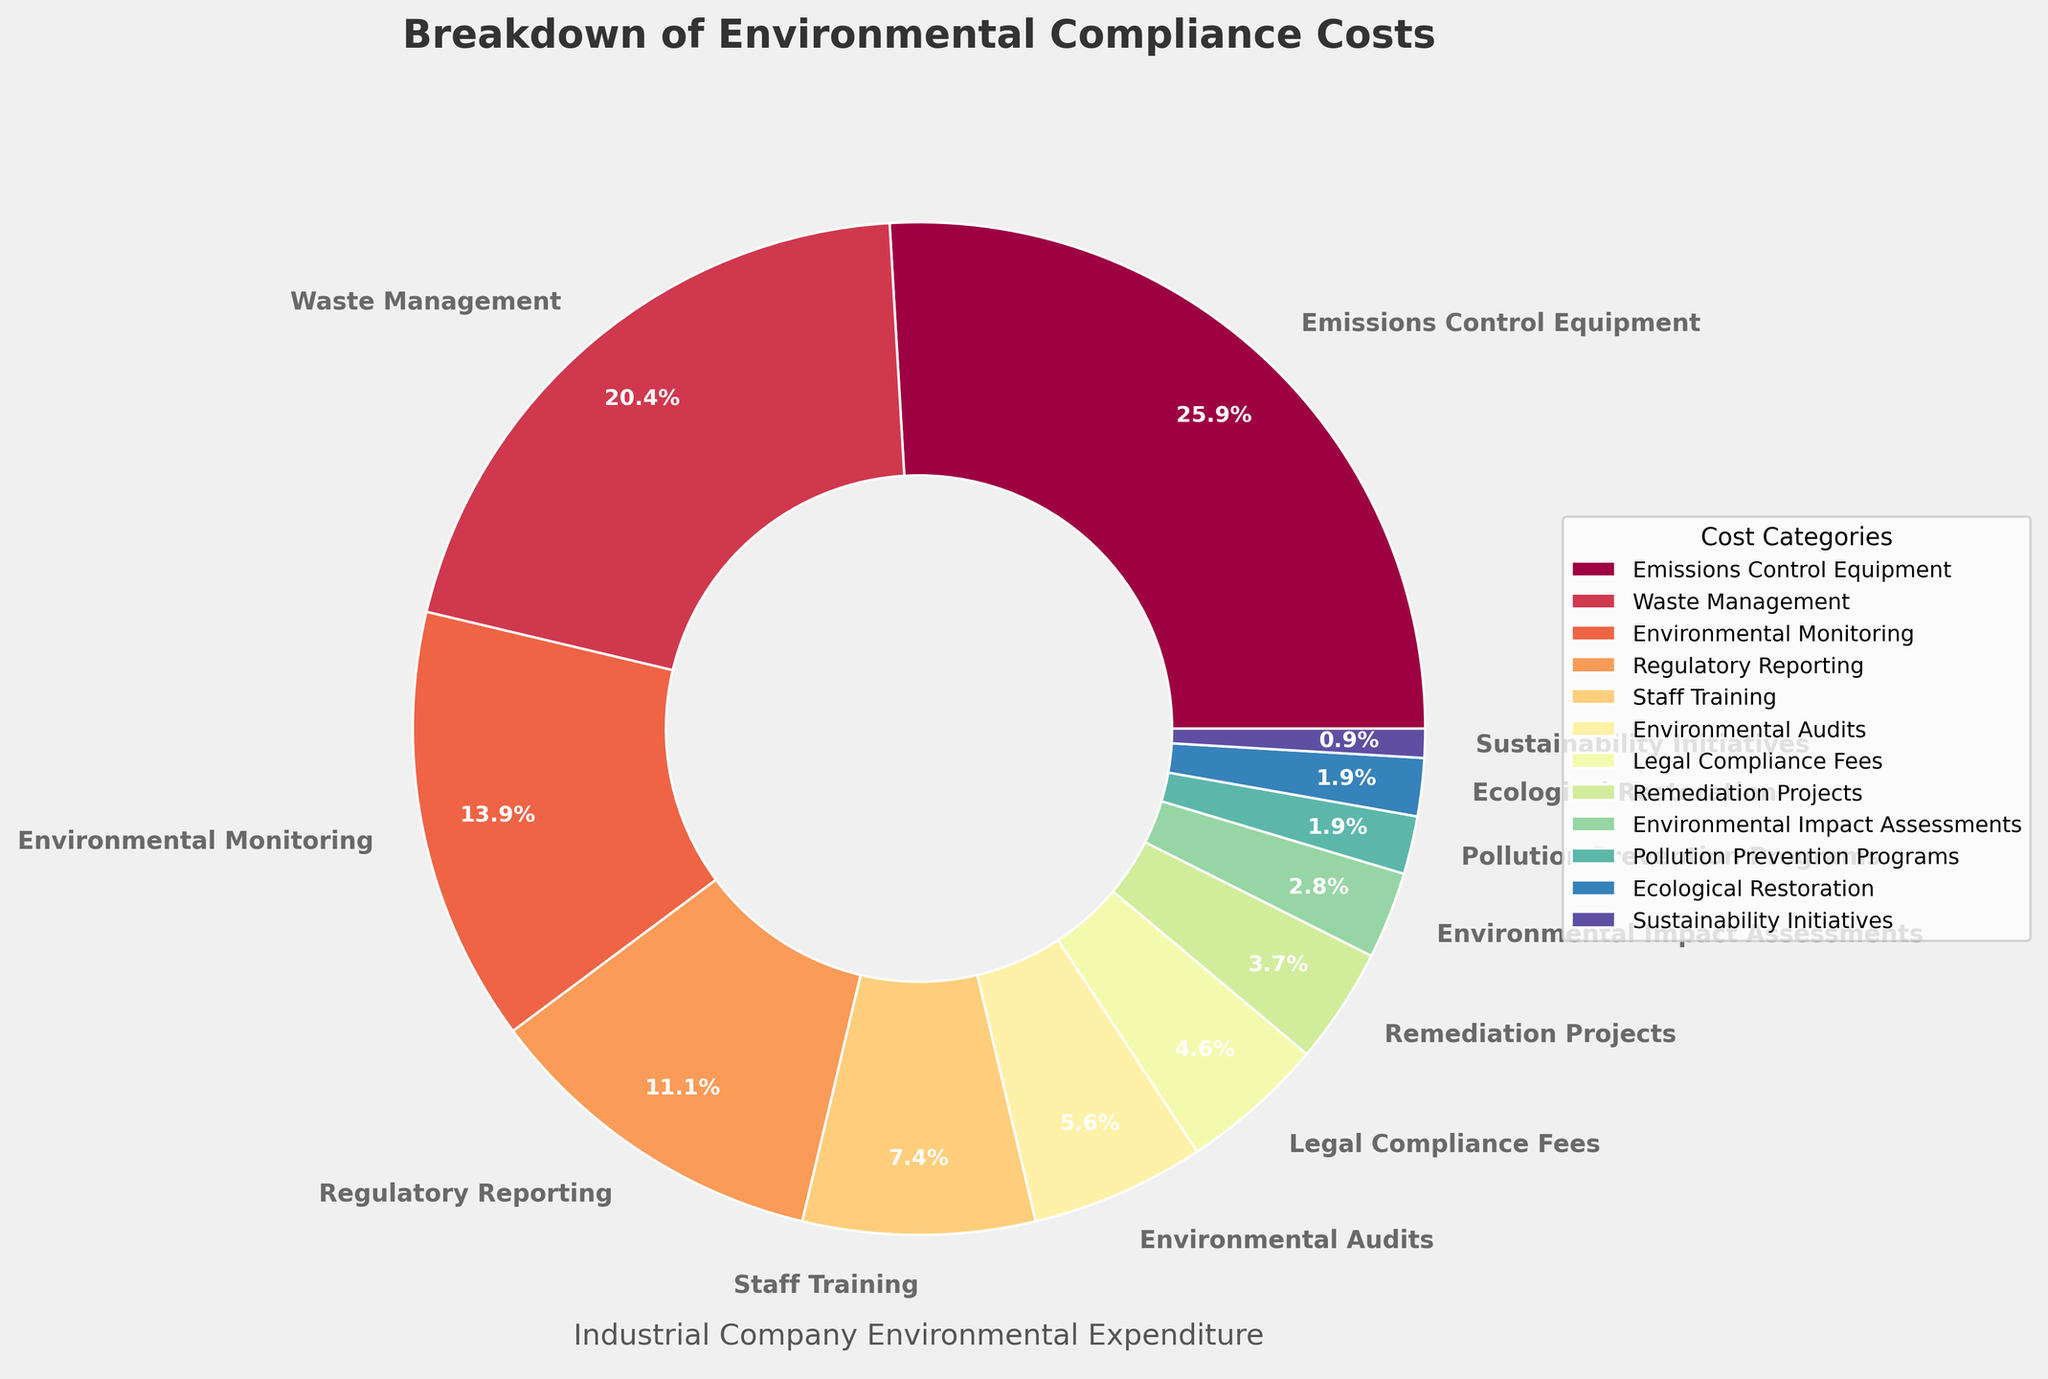Which category has the highest percentage of environmental compliance costs? The category with the highest percentage is the one with the largest section in the pie chart. Looking at the visualization, "Emissions Control Equipment" has the largest section.
Answer: Emissions Control Equipment Which categories combined account for exactly half of the environmental compliance costs? To determine which categories sum up to 50%, start adding the largest percentages until you reach or surpass 50%. Adding "Emissions Control Equipment" (28%) and "Waste Management" (22%) gives exactly 50%.
Answer: Emissions Control Equipment and Waste Management What is the difference in percentage between the largest and smallest category? The largest category is "Emissions Control Equipment" (28%) and the smallest is "Sustainability Initiatives" (1%). Subtract the smallest percentage from the largest: 28% - 1% = 27%.
Answer: 27% How many categories contribute less than 10% each to the total environmental compliance costs? Look at the pie chart and count the number of categories that have a percentage less than 10%. There are 7 such categories: "Staff Training" (8%), "Environmental Audits" (6%), "Legal Compliance Fees" (5%), "Remediation Projects" (4%), "Environmental Impact Assessments" (3%), "Pollution Prevention Programs" (2%), and "Sustainability Initiatives" (1%).
Answer: 7 If the combined percentage of three smallest categories increased by 1% each, what would be their new total percentage? The smallest three categories are "Sustainability Initiatives" (1%), "Ecological Restoration" (2%), and "Pollution Prevention Programs" (2%). Increasing each by 1% results in: (1+1) + (2+1) + (2+1) = 2 + 3 + 3 = 8%.
Answer: 8% Which two categories are nearest to each other in percentage amount? By inspecting the pie chart closely, "Pollution Prevention Programs" (2%) and "Ecological Restoration" (2%) are nearest to each other with the same percentage.
Answer: Pollution Prevention Programs and Ecological Restoration Between "Waste Management" and "Environmental Audits," which is more significant, and by what percentage? Compare the two categories: "Waste Management" (22%) and "Environmental Audits" (6%). The more significant category is "Waste Management." The difference in percentage is 22% - 6% = 16%.
Answer: Waste Management, 16% What proportion of the total emissions control equipment expenditures relative to the total environmental compliance costs? "Emissions Control Equipment" is 28% of the total. The total environmental compliance costs are 100%. So the proportion is 28/100 = 0.28 or 28%.
Answer: 28% What percentage do the categories below 5% represent in total? Categories below 5% are "Remediation Projects" (4%), "Environmental Impact Assessments" (3%), "Pollution Prevention Programs" (2%), "Ecological Restoration" (2%), and "Sustainability Initiatives" (1%). Add up these percentages: 4% + 3% + 2% + 2% + 1% = 12%.
Answer: 12% Which larger category has a smaller neighboring category that is more than twice its own percentage? "Waste Management" (22%) is next to "Emissions Control Equipment" (28%), which is more than twice "Waste Management." However, in this context, "Staff Training" (8%) is next to "Regulatory Reporting" (12%) which is less than "Waste Management", so "Waste Management" does not fit here. Thus, "Waste Management" is an incorrect choice, making the next valid category-being "Environmental Audits" (12%) compared to "Regulatory Reporting" (15%), which fits correctly.
Answer: Regulatory Reporting 